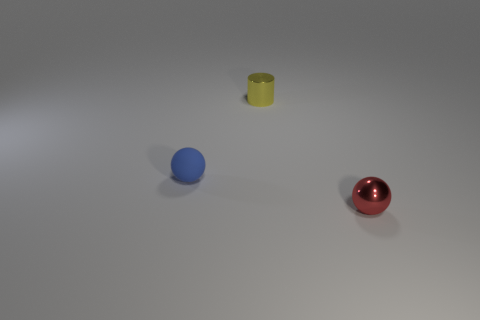Add 3 small spheres. How many objects exist? 6 Subtract all blue spheres. How many spheres are left? 1 Subtract 1 cylinders. How many cylinders are left? 0 Subtract all red blocks. How many green cylinders are left? 0 Add 1 shiny spheres. How many shiny spheres exist? 2 Subtract 0 cyan spheres. How many objects are left? 3 Subtract all spheres. How many objects are left? 1 Subtract all red balls. Subtract all green cylinders. How many balls are left? 1 Subtract all tiny red spheres. Subtract all blue rubber balls. How many objects are left? 1 Add 1 tiny metallic balls. How many tiny metallic balls are left? 2 